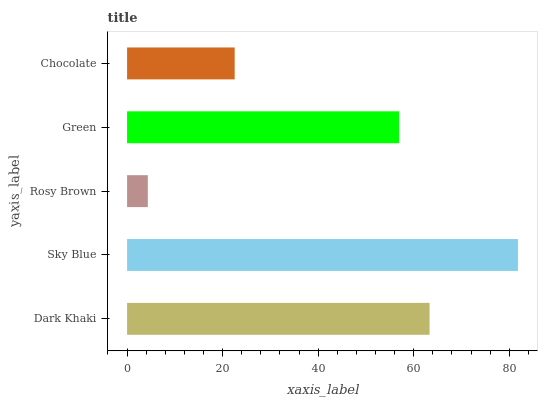Is Rosy Brown the minimum?
Answer yes or no. Yes. Is Sky Blue the maximum?
Answer yes or no. Yes. Is Sky Blue the minimum?
Answer yes or no. No. Is Rosy Brown the maximum?
Answer yes or no. No. Is Sky Blue greater than Rosy Brown?
Answer yes or no. Yes. Is Rosy Brown less than Sky Blue?
Answer yes or no. Yes. Is Rosy Brown greater than Sky Blue?
Answer yes or no. No. Is Sky Blue less than Rosy Brown?
Answer yes or no. No. Is Green the high median?
Answer yes or no. Yes. Is Green the low median?
Answer yes or no. Yes. Is Rosy Brown the high median?
Answer yes or no. No. Is Dark Khaki the low median?
Answer yes or no. No. 